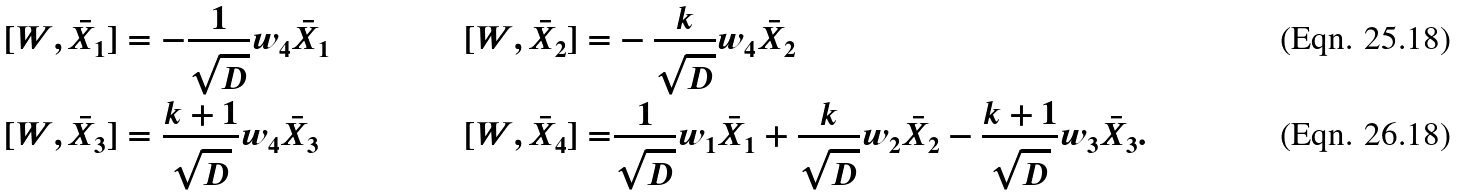Convert formula to latex. <formula><loc_0><loc_0><loc_500><loc_500>& [ W , \bar { X } _ { 1 } ] = - \frac { 1 } { \sqrt { D } } w _ { 4 } \bar { X } _ { 1 } & [ W , \bar { X } _ { 2 } ] = & - \frac { k } { \sqrt { D } } w _ { 4 } \bar { X } _ { 2 } \\ & [ W , \bar { X } _ { 3 } ] = \frac { k + 1 } { \sqrt { D } } w _ { 4 } \bar { X } _ { 3 } & [ W , \bar { X } _ { 4 } ] = & \frac { 1 } { \sqrt { D } } w _ { 1 } \bar { X } _ { 1 } + \frac { k } { \sqrt { D } } w _ { 2 } \bar { X } _ { 2 } - \frac { k + 1 } { \sqrt { D } } w _ { 3 } \bar { X } _ { 3 } .</formula> 